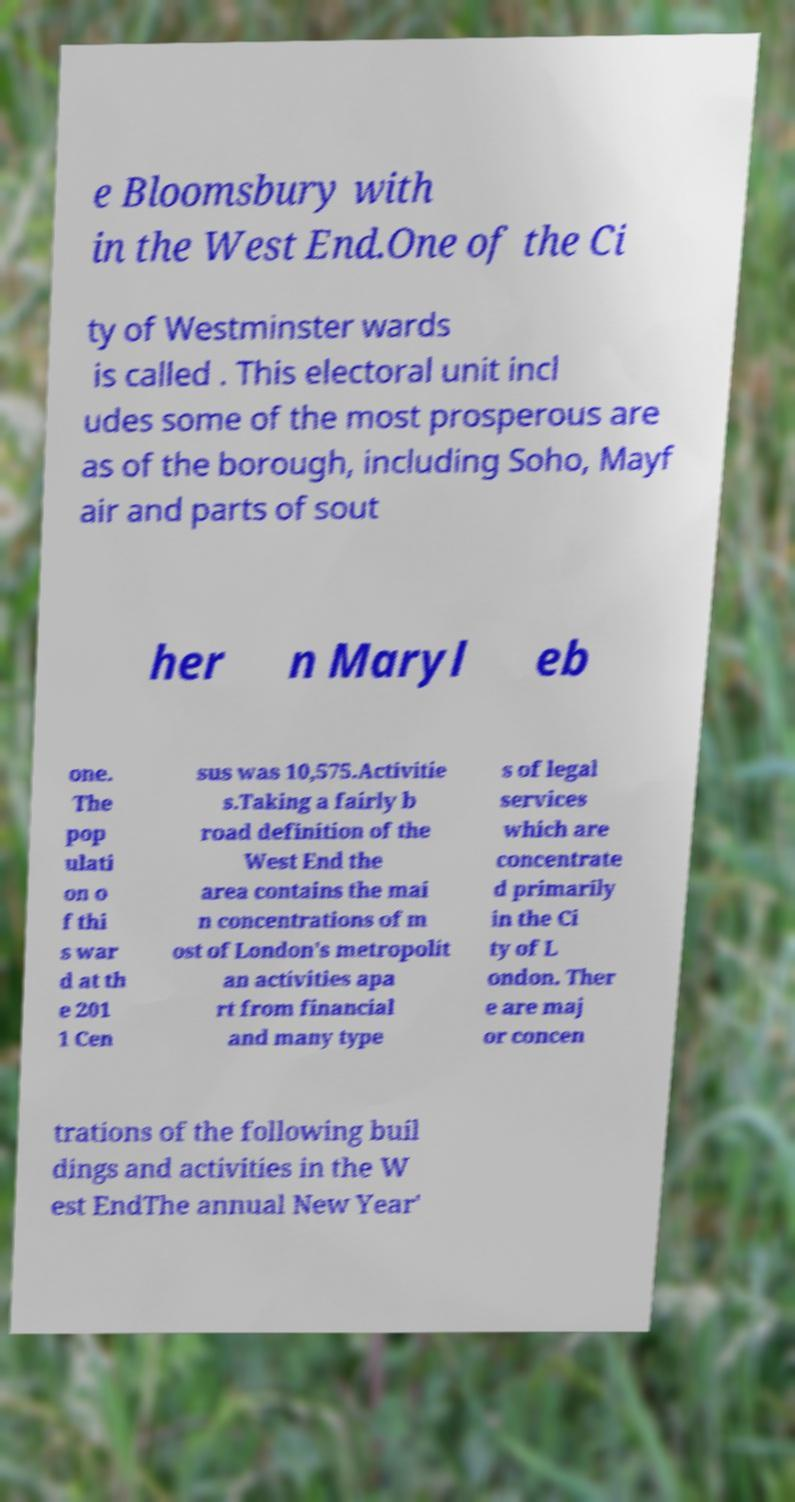I need the written content from this picture converted into text. Can you do that? e Bloomsbury with in the West End.One of the Ci ty of Westminster wards is called . This electoral unit incl udes some of the most prosperous are as of the borough, including Soho, Mayf air and parts of sout her n Maryl eb one. The pop ulati on o f thi s war d at th e 201 1 Cen sus was 10,575.Activitie s.Taking a fairly b road definition of the West End the area contains the mai n concentrations of m ost of London's metropolit an activities apa rt from financial and many type s of legal services which are concentrate d primarily in the Ci ty of L ondon. Ther e are maj or concen trations of the following buil dings and activities in the W est EndThe annual New Year' 